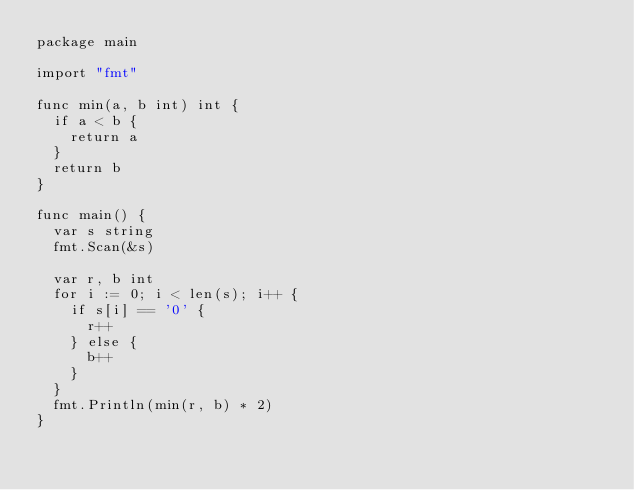Convert code to text. <code><loc_0><loc_0><loc_500><loc_500><_Go_>package main

import "fmt"

func min(a, b int) int {
	if a < b {
		return a
	}
	return b
}

func main() {
	var s string
	fmt.Scan(&s)

	var r, b int
	for i := 0; i < len(s); i++ {
		if s[i] == '0' {
			r++
		} else {
			b++
		}
	}
	fmt.Println(min(r, b) * 2)
}
</code> 